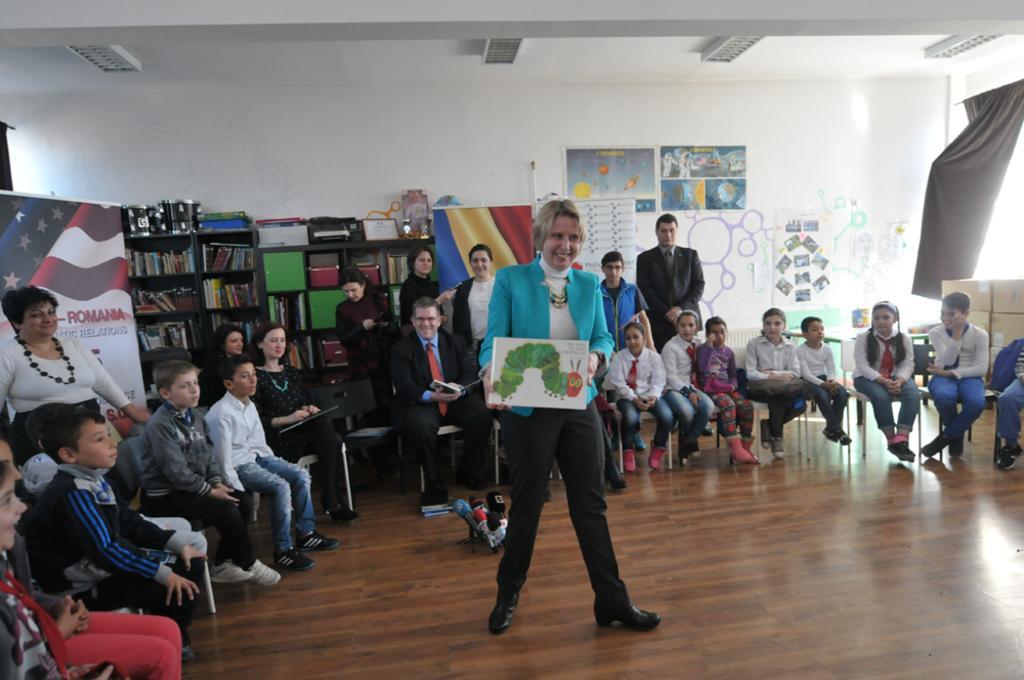Describe this image in one or two sentences. This picture describes about group of people, few are seated on the chairs and few are standing, in the background we can see few hoardings, books and other things in the racks, and also we can find few posters on the wall, on top of them we can see few lights, on the right side of the image we can find few boxes and curtains. 